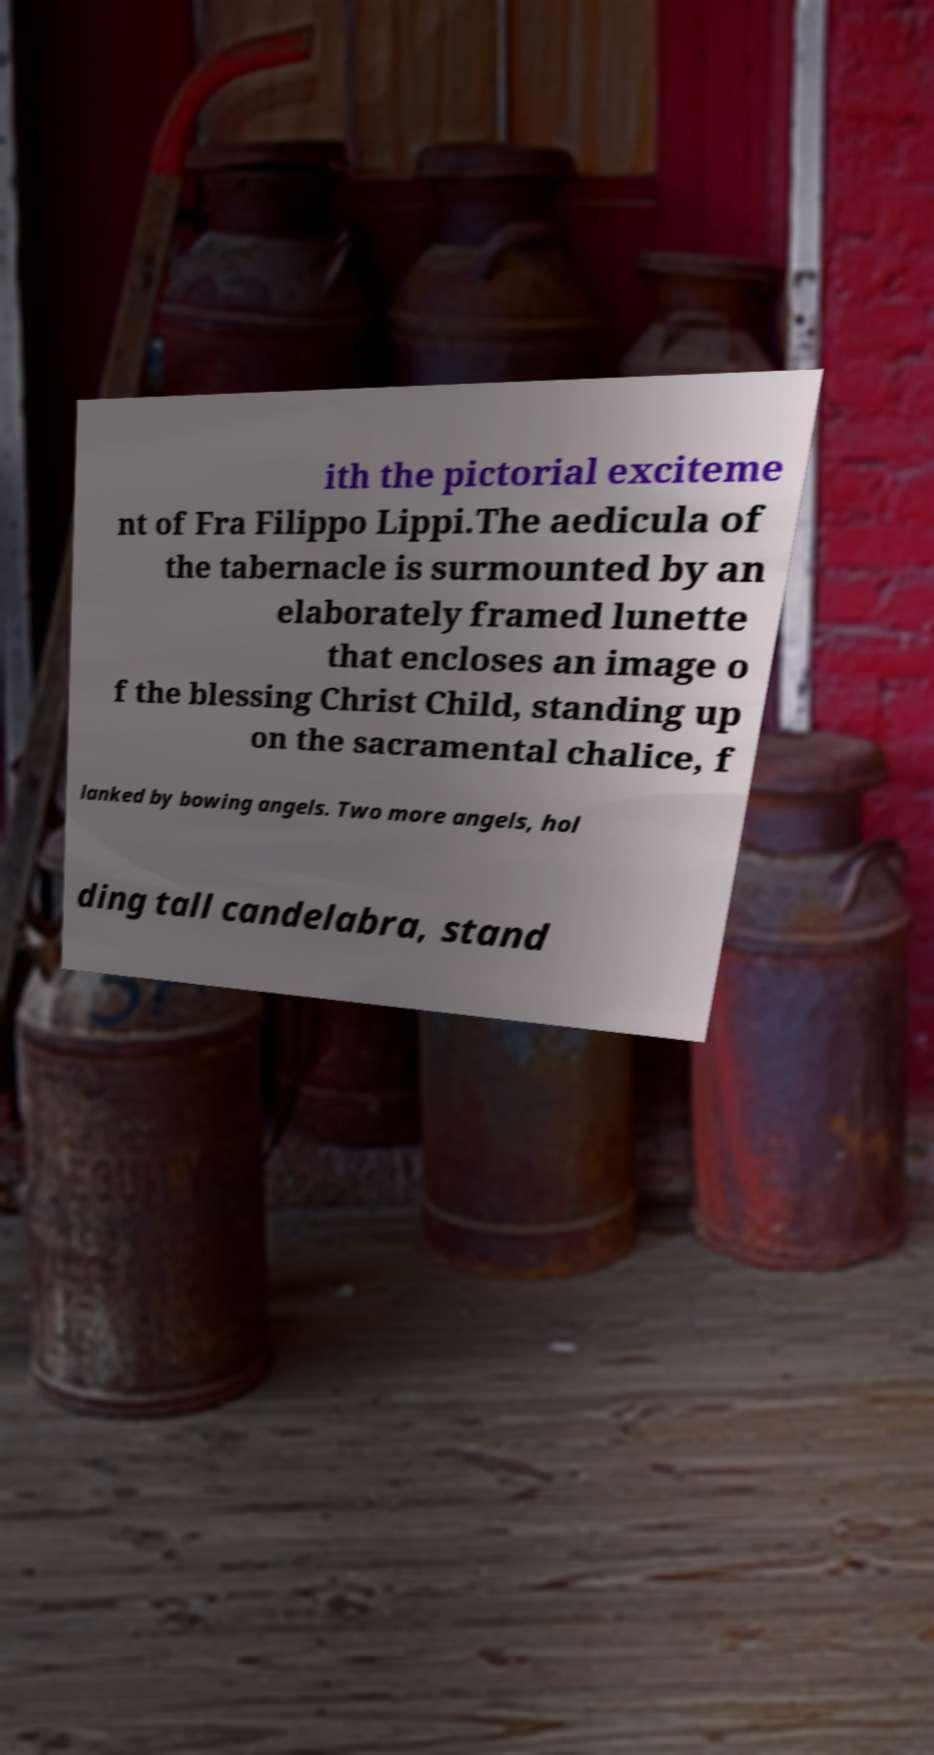I need the written content from this picture converted into text. Can you do that? ith the pictorial exciteme nt of Fra Filippo Lippi.The aedicula of the tabernacle is surmounted by an elaborately framed lunette that encloses an image o f the blessing Christ Child, standing up on the sacramental chalice, f lanked by bowing angels. Two more angels, hol ding tall candelabra, stand 